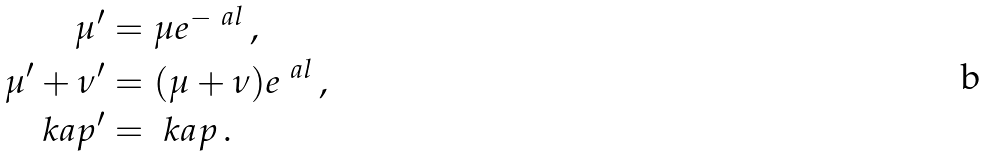<formula> <loc_0><loc_0><loc_500><loc_500>\mu ^ { \prime } & = \mu e ^ { - \ a l } \, , \\ \mu ^ { \prime } + \nu ^ { \prime } & = ( \mu + \nu ) e ^ { \ a l } \, , \\ \ k a p ^ { \prime } & = \ k a p \, .</formula> 